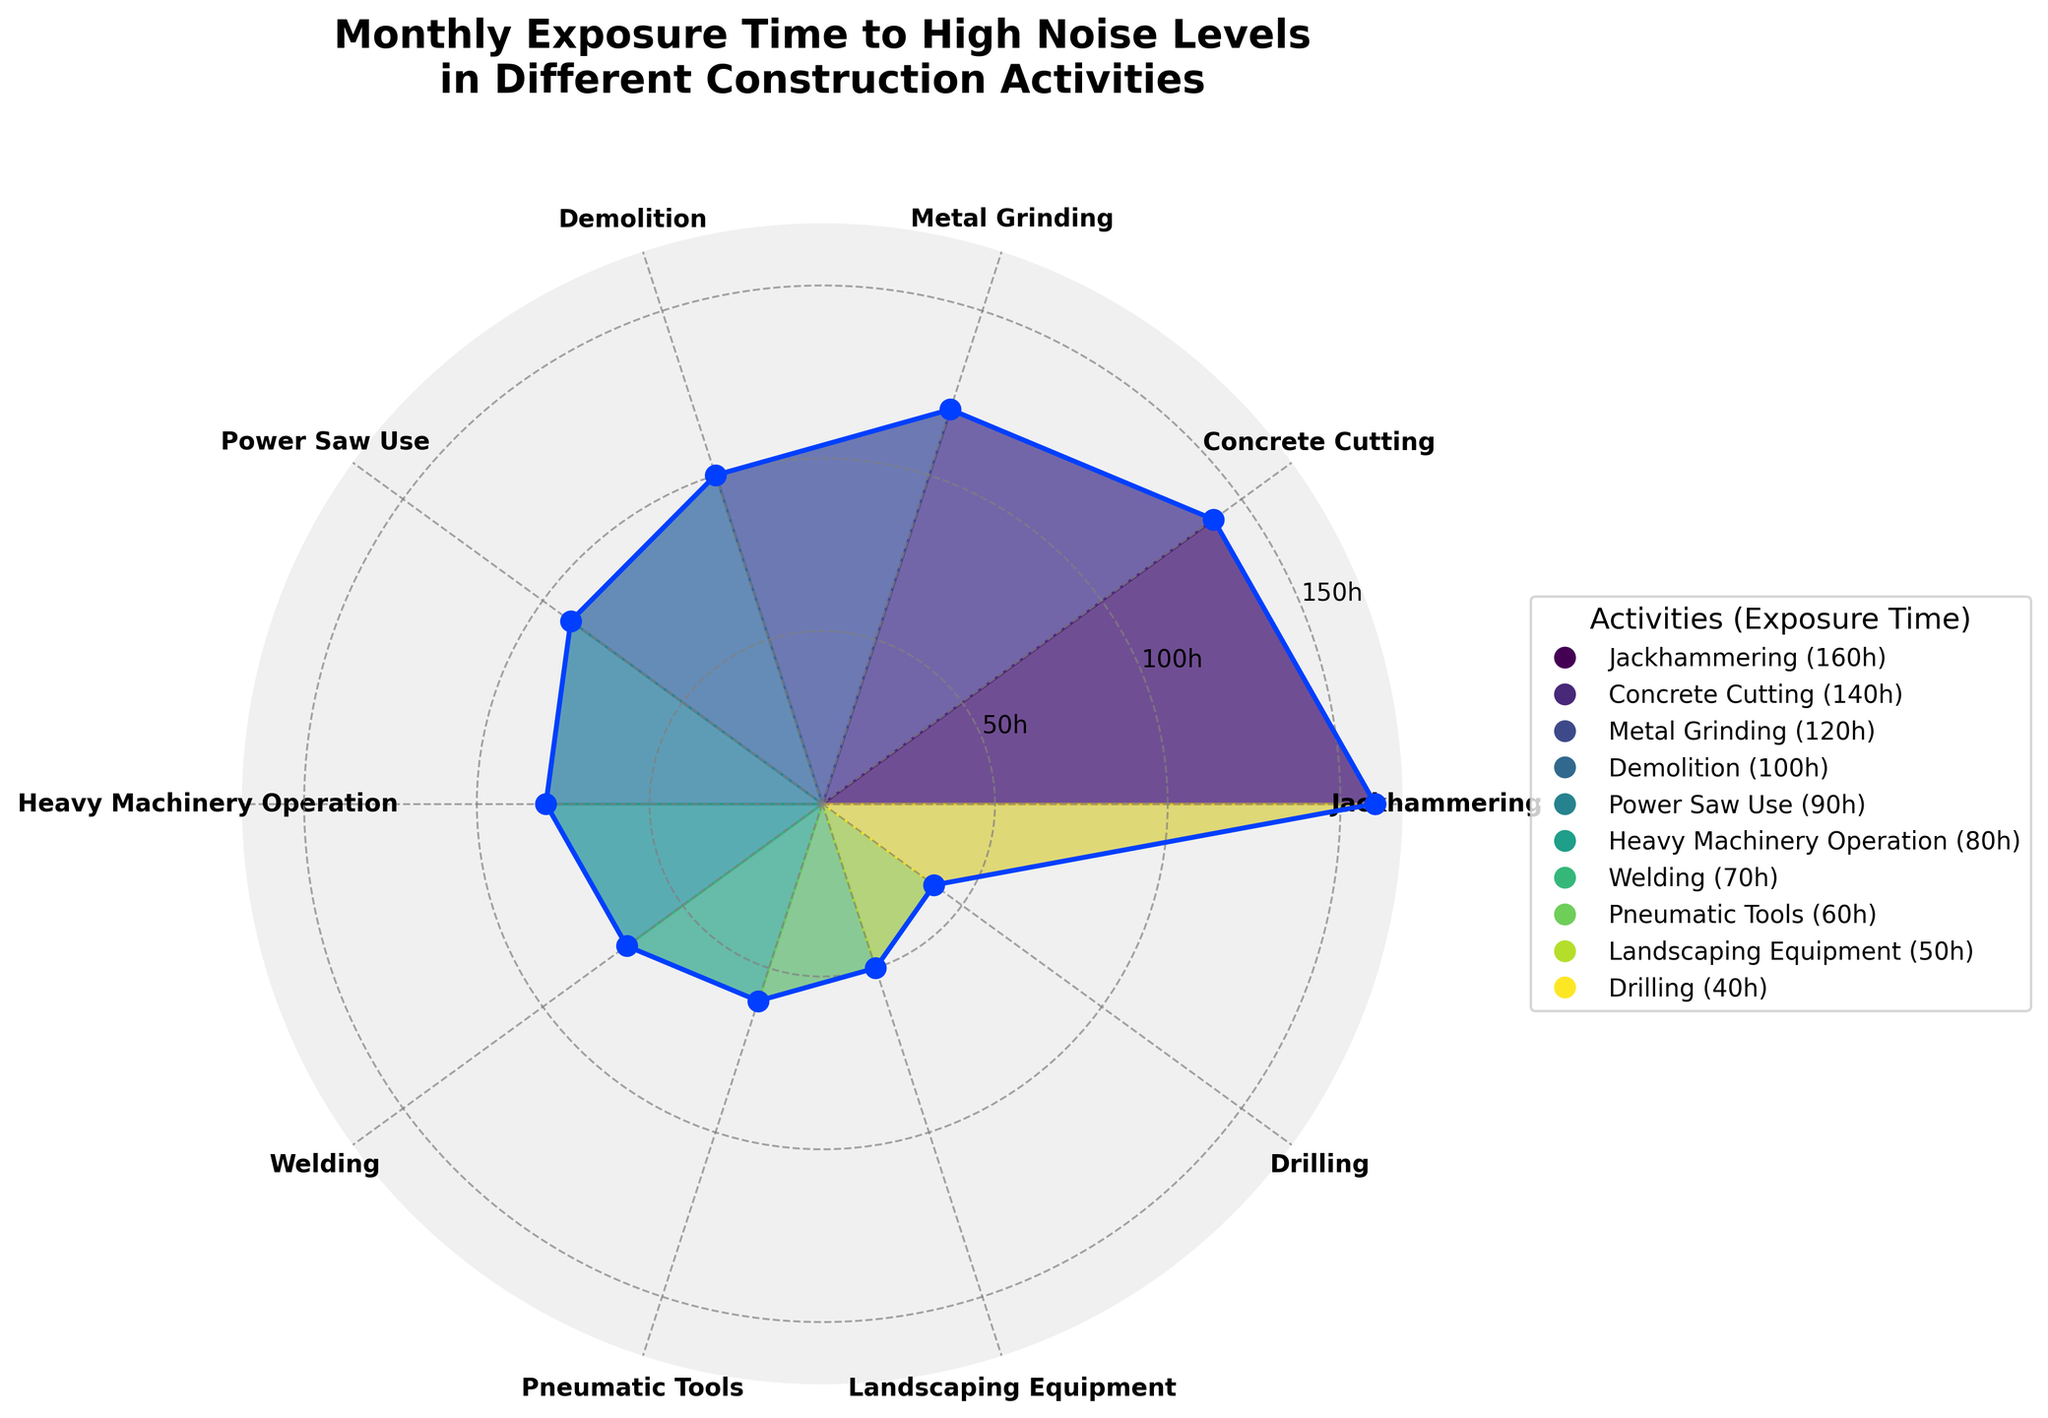What is the title of the chart? The title of the chart can be found at the top of the figure. It usually provides a summary of what the chart is about. In this figure, the title reads "Monthly Exposure Time to High Noise Levels in Different Construction Activities."
Answer: Monthly Exposure Time to High Noise Levels in Different Construction Activities How many construction activities are represented in the chart? To find the number of construction activities, count the number of segments or labels around the polar plot. Each segment represents an activity. There are ten labels from "Jackhammering" to "Drilling."
Answer: 10 Which construction activity has the highest monthly exposure time? To find the activity with the highest exposure time, look for the segment that extends the furthest from the center of the polar plot. "Jackhammering" has the longest segment at 160 hours.
Answer: Jackhammering What is the monthly exposure time for Concrete Cutting? To find the monthly exposure time for a specific activity, look for the corresponding label on the plot and note the length of the segment. "Concrete Cutting" extends to 140 hours.
Answer: 140 hours Which two construction activities have the least monthly exposure time, and what are their exposure times? To find the activities with the least exposure time, look for the segments that are closest to the center of the plot. "Drilling" and "Landscaping Equipment" are the smallest segments, with 40 hours and 50 hours, respectively.
Answer: Drilling: 40 hours, Landscaping Equipment: 50 hours How much higher is the exposure time for Jackhammering compared to Welding? To compare the exposure time of two activities, subtract the exposure time of the smaller activity from the larger one. Jackhammering is 160 hours, and Welding is 70 hours. The difference is \(160 - 70\).
Answer: 90 hours What is the total monthly exposure time for the top three activities? To find the total exposure time for the top three activities, identify the top three (Jackhammering, Concrete Cutting, Metal Grinding) and sum their exposure times \(160 + 140 + 120\).
Answer: 420 hours On average, how many hours do workers spend on activities exceeding 100 hours per month? First, identify activities that exceed 100 hours per month: Jackhammering, Concrete Cutting, Metal Grinding, and Demolition. Sum their exposure times \(160 + 140 + 120 + 100\) and divide by the number of activities (4). \(520 / 4\).
Answer: 130 hours How does the exposure time for Heavy Machinery Operation compare to the average exposure time for all activities? First, calculate the average exposure time: sum all times \(160 + 140 + 120 + 100 + 90 + 80 + 70 + 60 + 50 + 40\) and divide by 10. The average is 91 hours. Then compare this to Heavy Machinery Operation (80 hours), noting if it is greater, less, or equal.
Answer: Less How is the exposure time distributed across the activities, according to the polar area chart, and what does this tell you about noise exposure on the job site? The exposure time distribution can be observed by looking at the segments' lengths. Activities such as Jackhammering and Concrete Cutting dominate, indicating that these activities contribute the most to noise exposure. This suggests that the areas where these activities are performed need more focus on hearing protection.
Answer: Dominated by high-exposure activities like Jackhammering and Concrete Cutting 